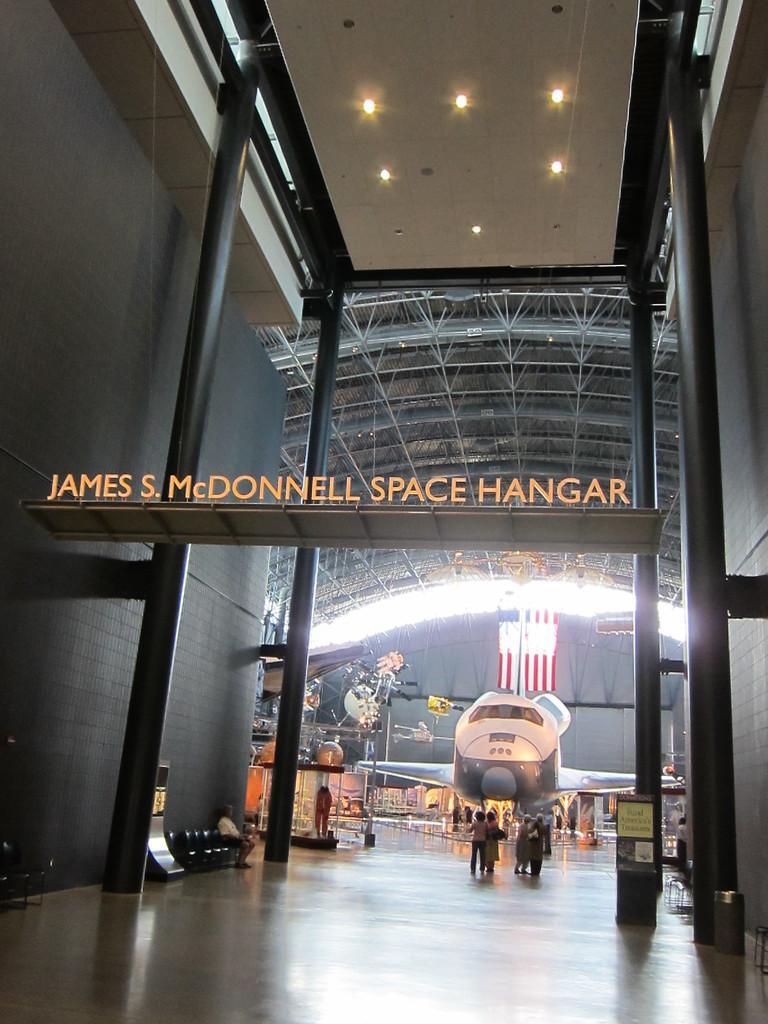Could you give a brief overview of what you see in this image? In this image, we can see an aircraft. There are a few people. We can see the ground. There are a few pillars. We can see the shed and some lights. We can see the ground with some objects. We can also see a flag. We can see some posters with text. 